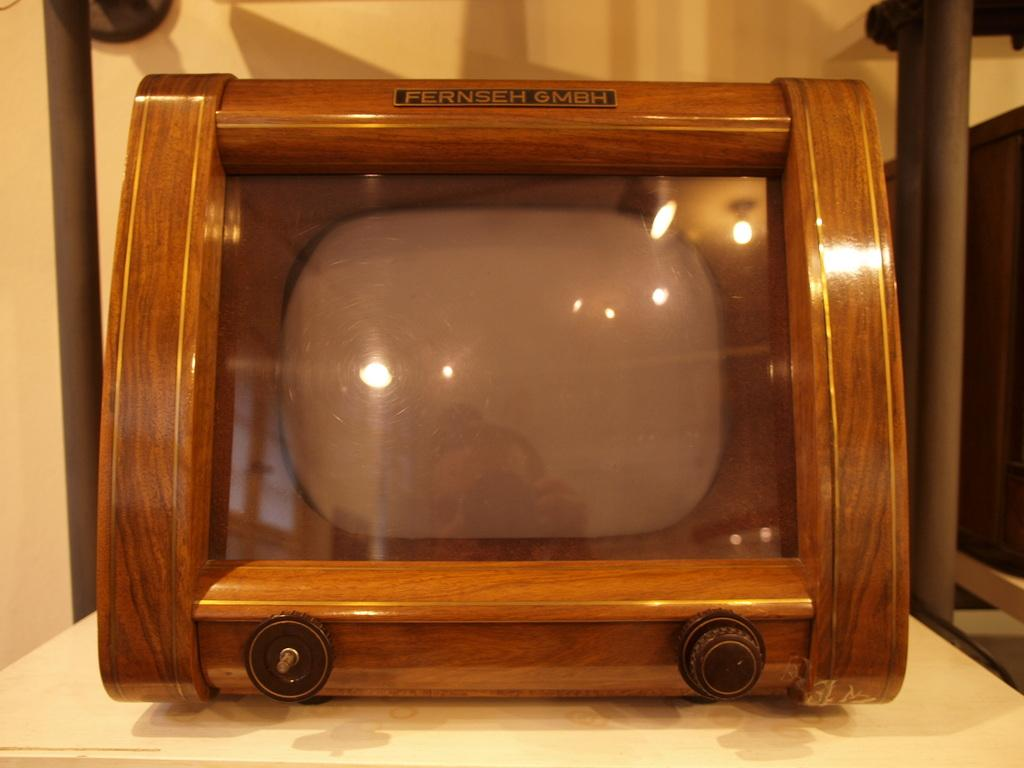<image>
Summarize the visual content of the image. The table has an old fashioned Fernseh GMBH television set. 